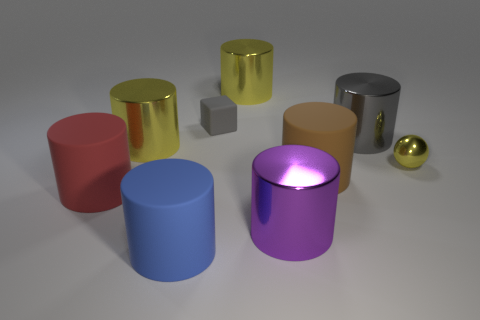Subtract 3 cylinders. How many cylinders are left? 4 Subtract all red matte cylinders. How many cylinders are left? 6 Subtract all red cylinders. How many cylinders are left? 6 Subtract all brown cylinders. Subtract all red cubes. How many cylinders are left? 6 Add 1 large red things. How many objects exist? 10 Subtract all blocks. How many objects are left? 8 Subtract 1 blue cylinders. How many objects are left? 8 Subtract all large brown things. Subtract all blue matte cylinders. How many objects are left? 7 Add 6 large gray metal cylinders. How many large gray metal cylinders are left? 7 Add 3 large metal objects. How many large metal objects exist? 7 